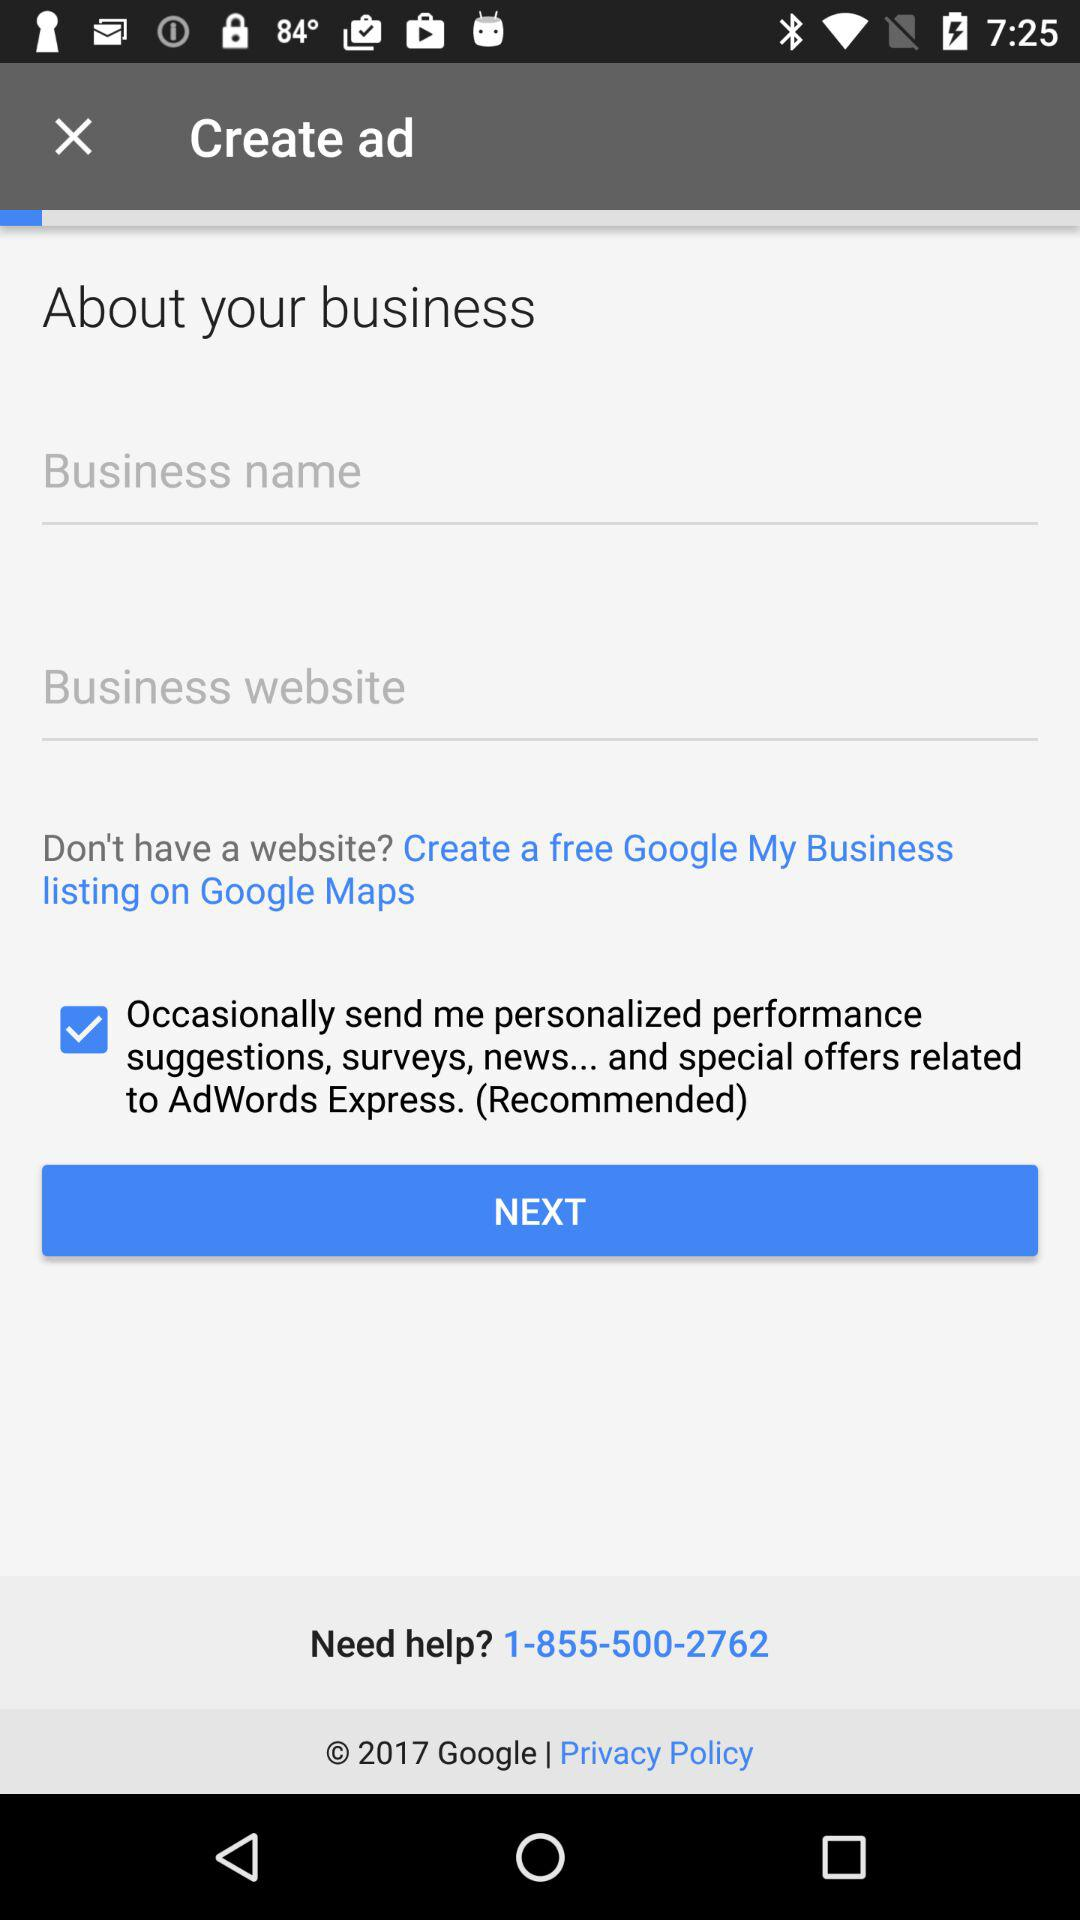What is the status of "Occasionally sending me personalized performance suggestions, surveys, news... and special offers related to AdWords Express."? The status is "on". 